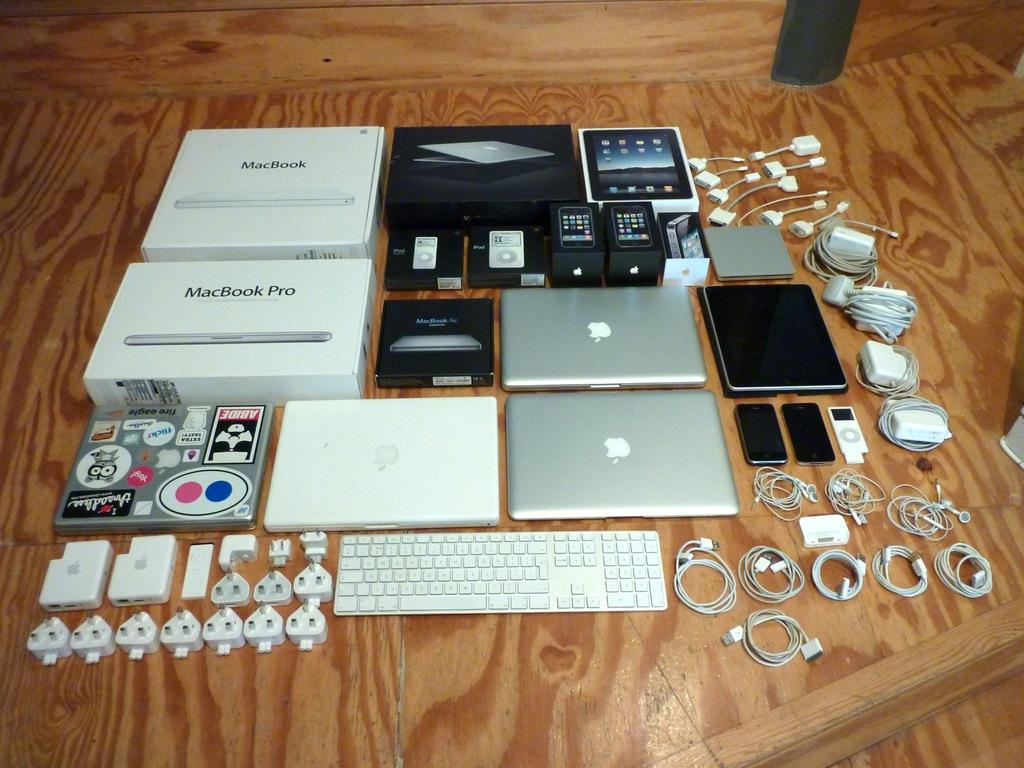<image>
Relay a brief, clear account of the picture shown. a series of apple products with some macbook boxes in there as well 